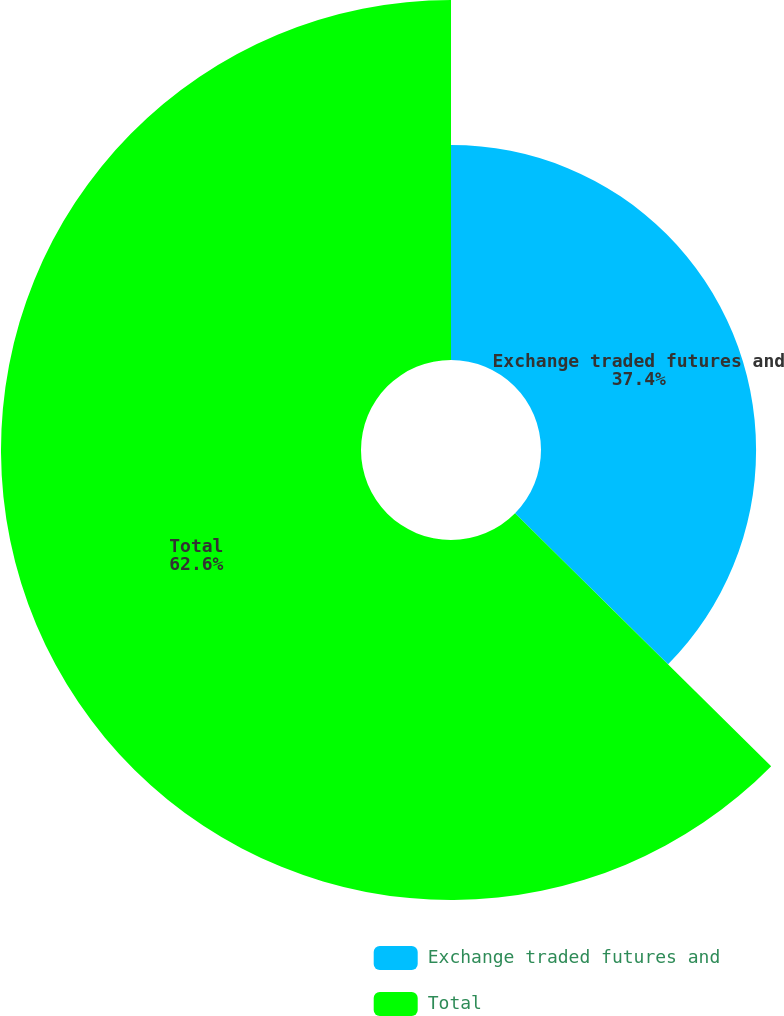Convert chart to OTSL. <chart><loc_0><loc_0><loc_500><loc_500><pie_chart><fcel>Exchange traded futures and<fcel>Total<nl><fcel>37.4%<fcel>62.6%<nl></chart> 